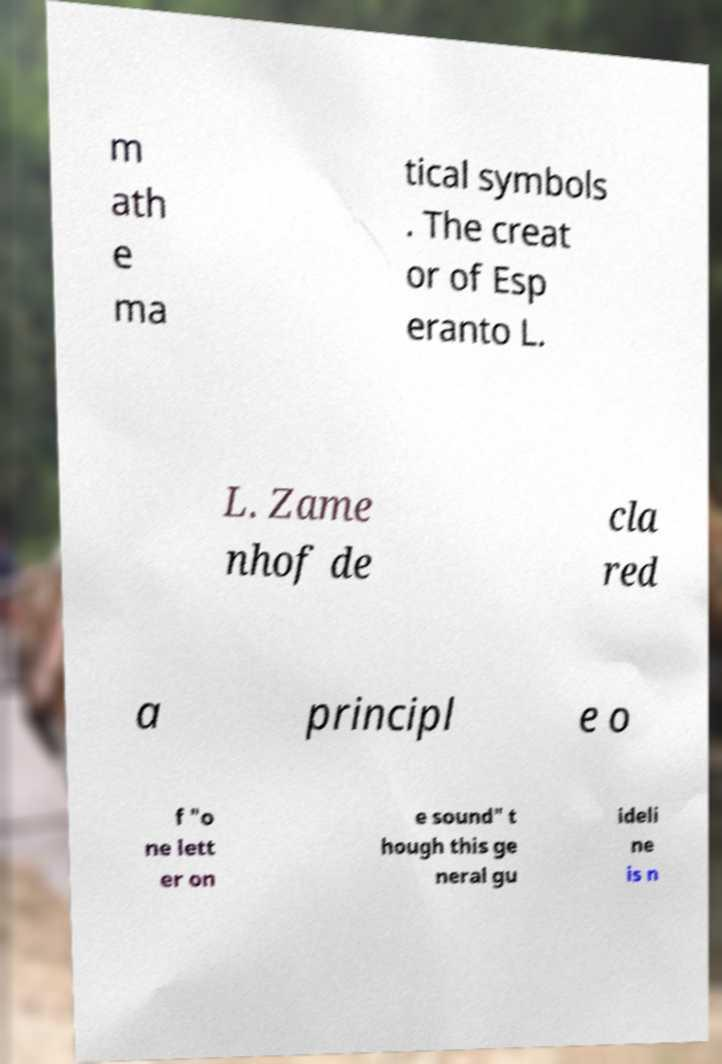There's text embedded in this image that I need extracted. Can you transcribe it verbatim? m ath e ma tical symbols . The creat or of Esp eranto L. L. Zame nhof de cla red a principl e o f "o ne lett er on e sound" t hough this ge neral gu ideli ne is n 